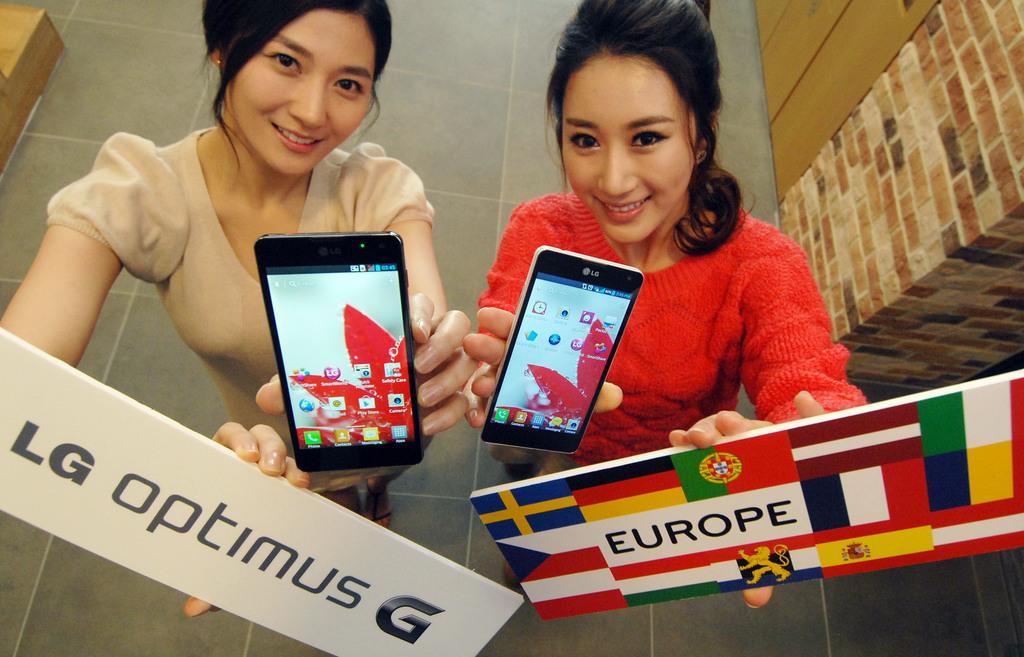What cellphone brand is the girl in red holding?
Make the answer very short. Lg. What country is represented on the small sign?
Provide a succinct answer. Europe. 